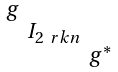<formula> <loc_0><loc_0><loc_500><loc_500>\begin{smallmatrix} g & & \\ & I _ { 2 { \ r k n } } & \\ & & g ^ { * } \end{smallmatrix}</formula> 